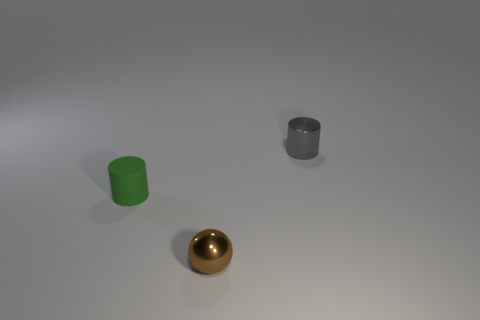Is the number of small gray objects less than the number of objects?
Give a very brief answer. Yes. There is a cylinder left of the brown ball; what is it made of?
Ensure brevity in your answer.  Rubber. There is a green thing that is the same size as the gray metallic cylinder; what is it made of?
Your answer should be very brief. Rubber. What is the small cylinder to the left of the tiny object behind the tiny cylinder that is in front of the metallic cylinder made of?
Provide a succinct answer. Rubber. Are there more tiny metal spheres than gray cubes?
Your answer should be very brief. Yes. What number of tiny objects are either shiny spheres or gray shiny cylinders?
Provide a succinct answer. 2. How many other objects are the same color as the ball?
Provide a succinct answer. 0. What number of gray cylinders have the same material as the brown thing?
Provide a succinct answer. 1. How many yellow objects are small shiny balls or rubber cylinders?
Provide a succinct answer. 0. Are there any other things that have the same material as the tiny green object?
Provide a short and direct response. No. 